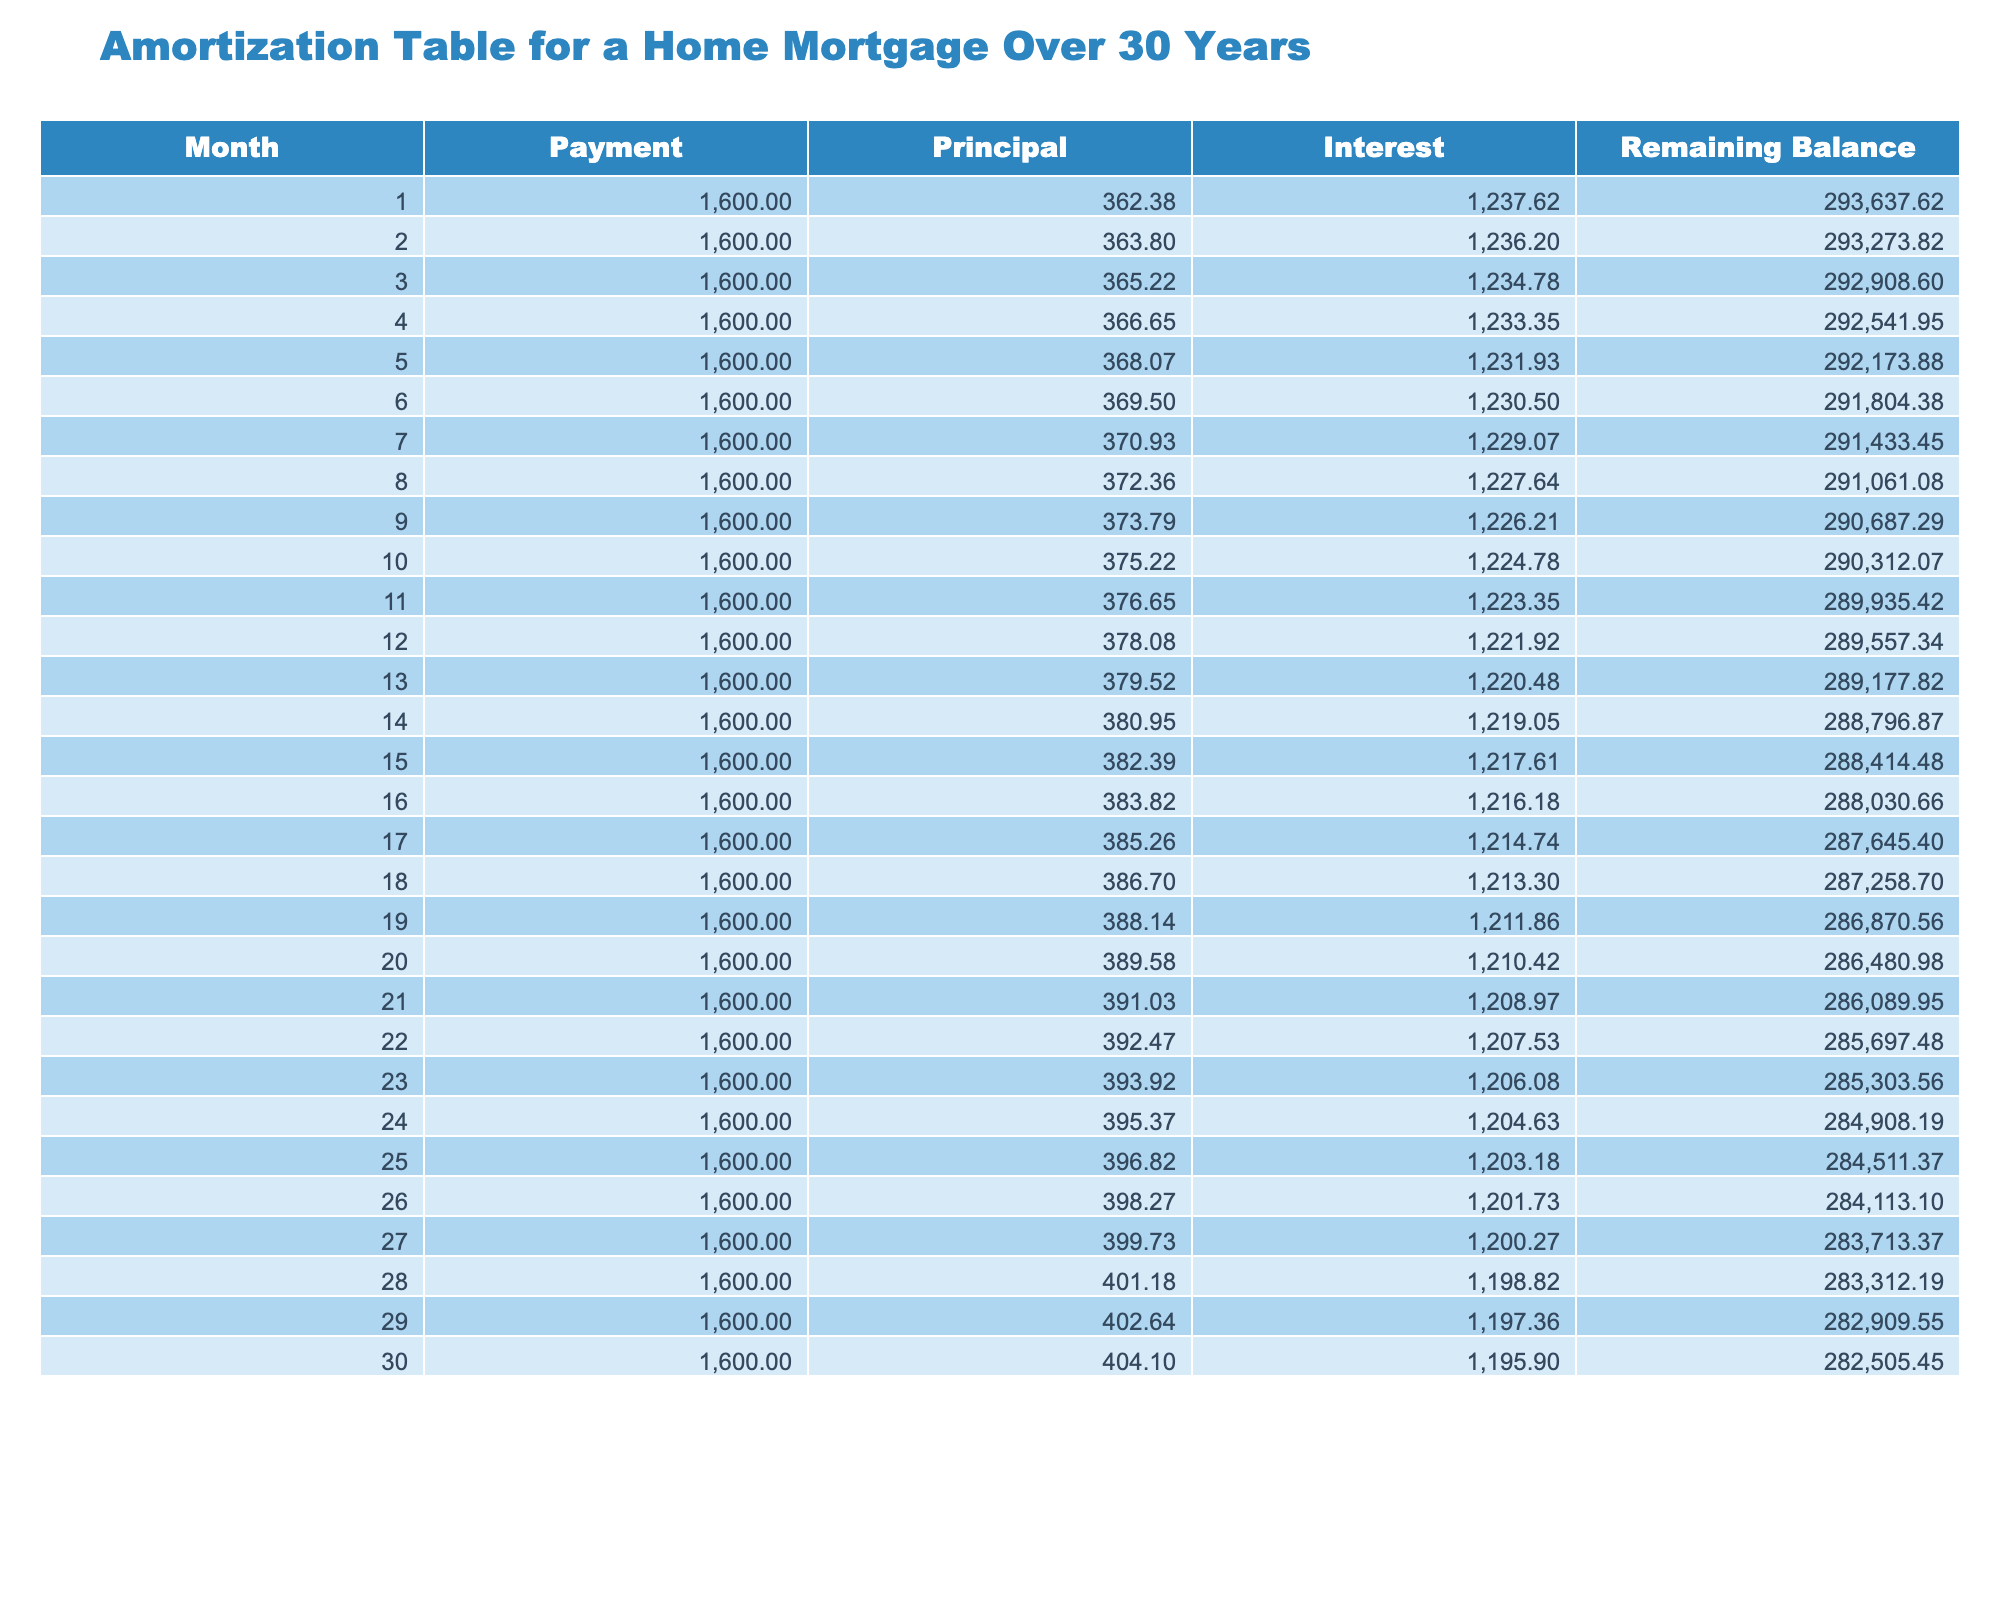What is the payment amount for the first month? The payment amount for the first month is given directly in the table under the "Payment" column for month 1, which shows 1600.00.
Answer: 1600.00 How much principal was paid off in the 15th month? The principal paid off in the 15th month is listed in the table under the column "Principal" for month 15, which shows 382.39.
Answer: 382.39 What is the total interest paid in the first 12 months? To find the total interest paid in the first 12 months, sum up the "Interest" column from months 1 to 12: 1237.62 + 1236.20 + 1234.78 + ... + 1221.92 = 14,733.96.
Answer: 14,733.96 Is the principal payment increasing or decreasing over the first 30 months? By examining the "Principal" column values, we see that each month's principal payment is greater than the previous month, indicating it is increasing.
Answer: Yes What is the average remaining balance over the first three months? To find the average remaining balance over the first three months, sum the remaining balances (293637.62 + 293273.82 + 292908.60) which equals 879820.04, and then divide by 3. The average is 293273.35.
Answer: 293273.35 How much total payment will be made by the end of the 30th month? To find the total payments made by the end of the 30th month, multiply the monthly payment amount by the number of months: 1600.00 * 30 = 48,000.00.
Answer: 48,000.00 Do the total principal payments exceed total interest payments in the first 30 months? To answer this, we summarize the principal and interest from the table: Total principal is the sum of the "Principal" column, and total interest is the sum of the "Interest" column. After calculating, we find total principal payments amount to 11,446.70, while total interest payments are 36,120.00. Thus, principal does not exceed interest.
Answer: No What is the change in remaining balance from month 1 to month 30? The change in the remaining balance is computed by taking the month 1 balance of 293637.62 and subtracting the month 30 balance of 282505.45: 293637.62 - 282505.45 = 11332.17.
Answer: 11332.17 